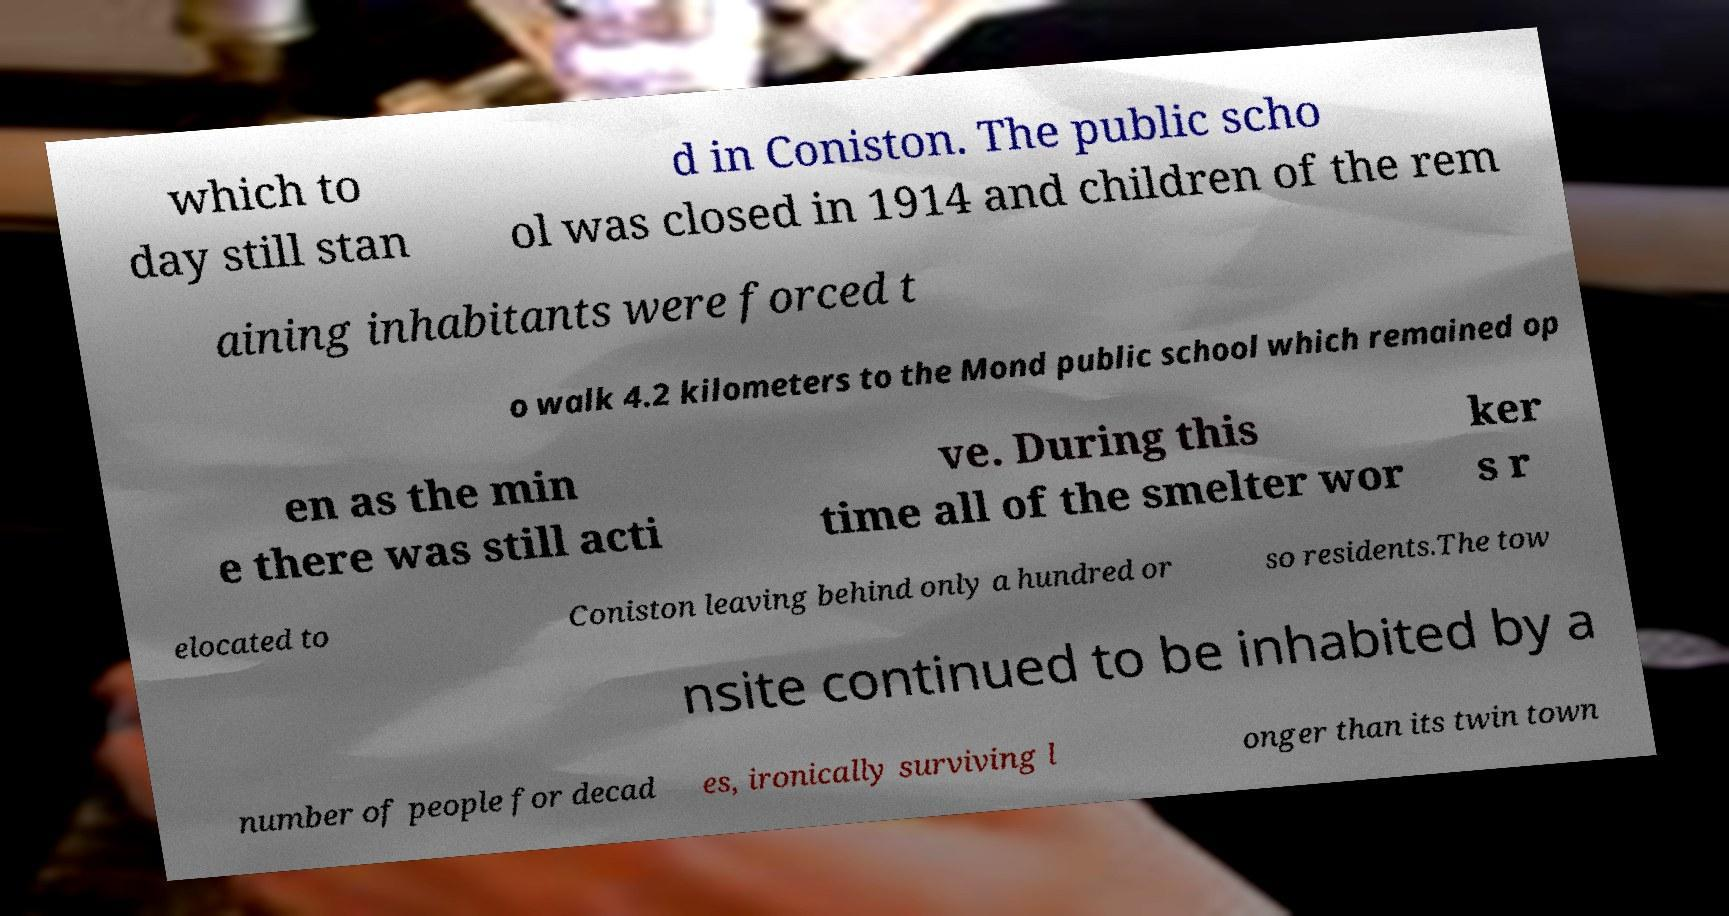I need the written content from this picture converted into text. Can you do that? which to day still stan d in Coniston. The public scho ol was closed in 1914 and children of the rem aining inhabitants were forced t o walk 4.2 kilometers to the Mond public school which remained op en as the min e there was still acti ve. During this time all of the smelter wor ker s r elocated to Coniston leaving behind only a hundred or so residents.The tow nsite continued to be inhabited by a number of people for decad es, ironically surviving l onger than its twin town 